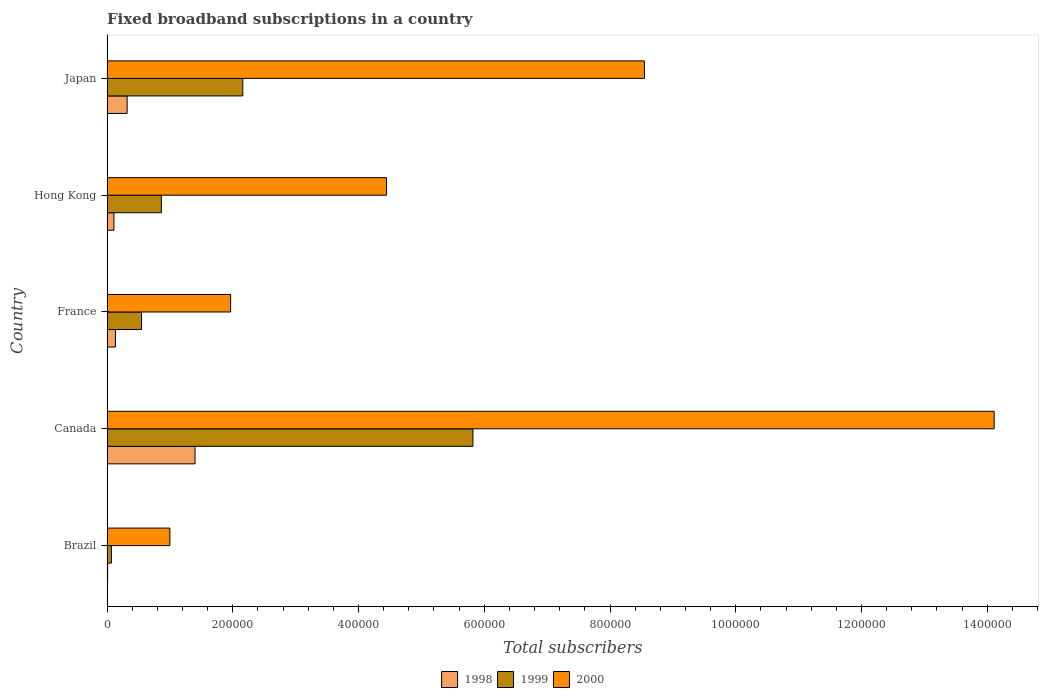How many different coloured bars are there?
Make the answer very short. 3. How many groups of bars are there?
Your answer should be very brief. 5. Are the number of bars on each tick of the Y-axis equal?
Ensure brevity in your answer.  Yes. How many bars are there on the 4th tick from the top?
Provide a succinct answer. 3. What is the label of the 5th group of bars from the top?
Make the answer very short. Brazil. What is the number of broadband subscriptions in 1998 in France?
Ensure brevity in your answer.  1.35e+04. Across all countries, what is the minimum number of broadband subscriptions in 1998?
Make the answer very short. 1000. In which country was the number of broadband subscriptions in 1998 maximum?
Your answer should be compact. Canada. In which country was the number of broadband subscriptions in 1998 minimum?
Make the answer very short. Brazil. What is the total number of broadband subscriptions in 2000 in the graph?
Provide a succinct answer. 3.01e+06. What is the difference between the number of broadband subscriptions in 1998 in Brazil and that in Canada?
Your response must be concise. -1.39e+05. What is the difference between the number of broadband subscriptions in 1999 in Hong Kong and the number of broadband subscriptions in 1998 in Brazil?
Offer a very short reply. 8.55e+04. What is the average number of broadband subscriptions in 1999 per country?
Offer a terse response. 1.89e+05. What is the difference between the number of broadband subscriptions in 1999 and number of broadband subscriptions in 2000 in France?
Give a very brief answer. -1.42e+05. In how many countries, is the number of broadband subscriptions in 2000 greater than 1240000 ?
Offer a terse response. 1. What is the ratio of the number of broadband subscriptions in 2000 in Brazil to that in Hong Kong?
Offer a very short reply. 0.22. Is the number of broadband subscriptions in 2000 in Canada less than that in Japan?
Offer a very short reply. No. What is the difference between the highest and the second highest number of broadband subscriptions in 1998?
Ensure brevity in your answer.  1.08e+05. What is the difference between the highest and the lowest number of broadband subscriptions in 1999?
Provide a succinct answer. 5.75e+05. What does the 1st bar from the bottom in Japan represents?
Ensure brevity in your answer.  1998. How many bars are there?
Give a very brief answer. 15. Are all the bars in the graph horizontal?
Your response must be concise. Yes. What is the difference between two consecutive major ticks on the X-axis?
Make the answer very short. 2.00e+05. Does the graph contain grids?
Offer a terse response. No. How are the legend labels stacked?
Provide a succinct answer. Horizontal. What is the title of the graph?
Keep it short and to the point. Fixed broadband subscriptions in a country. Does "1973" appear as one of the legend labels in the graph?
Make the answer very short. No. What is the label or title of the X-axis?
Provide a short and direct response. Total subscribers. What is the label or title of the Y-axis?
Your answer should be compact. Country. What is the Total subscribers of 1999 in Brazil?
Provide a succinct answer. 7000. What is the Total subscribers of 2000 in Brazil?
Your response must be concise. 1.00e+05. What is the Total subscribers of 1998 in Canada?
Give a very brief answer. 1.40e+05. What is the Total subscribers of 1999 in Canada?
Keep it short and to the point. 5.82e+05. What is the Total subscribers of 2000 in Canada?
Give a very brief answer. 1.41e+06. What is the Total subscribers of 1998 in France?
Keep it short and to the point. 1.35e+04. What is the Total subscribers in 1999 in France?
Offer a terse response. 5.50e+04. What is the Total subscribers of 2000 in France?
Your answer should be very brief. 1.97e+05. What is the Total subscribers of 1998 in Hong Kong?
Your answer should be very brief. 1.10e+04. What is the Total subscribers of 1999 in Hong Kong?
Keep it short and to the point. 8.65e+04. What is the Total subscribers of 2000 in Hong Kong?
Ensure brevity in your answer.  4.44e+05. What is the Total subscribers of 1998 in Japan?
Your response must be concise. 3.20e+04. What is the Total subscribers of 1999 in Japan?
Ensure brevity in your answer.  2.16e+05. What is the Total subscribers in 2000 in Japan?
Offer a very short reply. 8.55e+05. Across all countries, what is the maximum Total subscribers in 1999?
Your answer should be very brief. 5.82e+05. Across all countries, what is the maximum Total subscribers in 2000?
Keep it short and to the point. 1.41e+06. Across all countries, what is the minimum Total subscribers of 1998?
Offer a terse response. 1000. Across all countries, what is the minimum Total subscribers in 1999?
Provide a succinct answer. 7000. Across all countries, what is the minimum Total subscribers of 2000?
Give a very brief answer. 1.00e+05. What is the total Total subscribers in 1998 in the graph?
Keep it short and to the point. 1.97e+05. What is the total Total subscribers in 1999 in the graph?
Provide a short and direct response. 9.46e+05. What is the total Total subscribers in 2000 in the graph?
Your answer should be very brief. 3.01e+06. What is the difference between the Total subscribers of 1998 in Brazil and that in Canada?
Give a very brief answer. -1.39e+05. What is the difference between the Total subscribers of 1999 in Brazil and that in Canada?
Ensure brevity in your answer.  -5.75e+05. What is the difference between the Total subscribers of 2000 in Brazil and that in Canada?
Offer a terse response. -1.31e+06. What is the difference between the Total subscribers in 1998 in Brazil and that in France?
Make the answer very short. -1.25e+04. What is the difference between the Total subscribers in 1999 in Brazil and that in France?
Your answer should be very brief. -4.80e+04. What is the difference between the Total subscribers in 2000 in Brazil and that in France?
Your response must be concise. -9.66e+04. What is the difference between the Total subscribers in 1999 in Brazil and that in Hong Kong?
Ensure brevity in your answer.  -7.95e+04. What is the difference between the Total subscribers in 2000 in Brazil and that in Hong Kong?
Ensure brevity in your answer.  -3.44e+05. What is the difference between the Total subscribers in 1998 in Brazil and that in Japan?
Offer a very short reply. -3.10e+04. What is the difference between the Total subscribers of 1999 in Brazil and that in Japan?
Offer a very short reply. -2.09e+05. What is the difference between the Total subscribers in 2000 in Brazil and that in Japan?
Your answer should be very brief. -7.55e+05. What is the difference between the Total subscribers in 1998 in Canada and that in France?
Provide a short and direct response. 1.27e+05. What is the difference between the Total subscribers of 1999 in Canada and that in France?
Provide a short and direct response. 5.27e+05. What is the difference between the Total subscribers of 2000 in Canada and that in France?
Your answer should be very brief. 1.21e+06. What is the difference between the Total subscribers in 1998 in Canada and that in Hong Kong?
Offer a terse response. 1.29e+05. What is the difference between the Total subscribers of 1999 in Canada and that in Hong Kong?
Make the answer very short. 4.96e+05. What is the difference between the Total subscribers in 2000 in Canada and that in Hong Kong?
Keep it short and to the point. 9.66e+05. What is the difference between the Total subscribers of 1998 in Canada and that in Japan?
Your answer should be compact. 1.08e+05. What is the difference between the Total subscribers of 1999 in Canada and that in Japan?
Make the answer very short. 3.66e+05. What is the difference between the Total subscribers in 2000 in Canada and that in Japan?
Give a very brief answer. 5.56e+05. What is the difference between the Total subscribers in 1998 in France and that in Hong Kong?
Keep it short and to the point. 2464. What is the difference between the Total subscribers in 1999 in France and that in Hong Kong?
Your answer should be very brief. -3.15e+04. What is the difference between the Total subscribers in 2000 in France and that in Hong Kong?
Your response must be concise. -2.48e+05. What is the difference between the Total subscribers in 1998 in France and that in Japan?
Give a very brief answer. -1.85e+04. What is the difference between the Total subscribers of 1999 in France and that in Japan?
Offer a very short reply. -1.61e+05. What is the difference between the Total subscribers of 2000 in France and that in Japan?
Provide a succinct answer. -6.58e+05. What is the difference between the Total subscribers of 1998 in Hong Kong and that in Japan?
Provide a short and direct response. -2.10e+04. What is the difference between the Total subscribers in 1999 in Hong Kong and that in Japan?
Make the answer very short. -1.30e+05. What is the difference between the Total subscribers of 2000 in Hong Kong and that in Japan?
Provide a short and direct response. -4.10e+05. What is the difference between the Total subscribers of 1998 in Brazil and the Total subscribers of 1999 in Canada?
Offer a very short reply. -5.81e+05. What is the difference between the Total subscribers of 1998 in Brazil and the Total subscribers of 2000 in Canada?
Your response must be concise. -1.41e+06. What is the difference between the Total subscribers in 1999 in Brazil and the Total subscribers in 2000 in Canada?
Your response must be concise. -1.40e+06. What is the difference between the Total subscribers of 1998 in Brazil and the Total subscribers of 1999 in France?
Provide a short and direct response. -5.40e+04. What is the difference between the Total subscribers of 1998 in Brazil and the Total subscribers of 2000 in France?
Offer a very short reply. -1.96e+05. What is the difference between the Total subscribers of 1999 in Brazil and the Total subscribers of 2000 in France?
Provide a succinct answer. -1.90e+05. What is the difference between the Total subscribers of 1998 in Brazil and the Total subscribers of 1999 in Hong Kong?
Ensure brevity in your answer.  -8.55e+04. What is the difference between the Total subscribers of 1998 in Brazil and the Total subscribers of 2000 in Hong Kong?
Your response must be concise. -4.43e+05. What is the difference between the Total subscribers of 1999 in Brazil and the Total subscribers of 2000 in Hong Kong?
Provide a succinct answer. -4.37e+05. What is the difference between the Total subscribers in 1998 in Brazil and the Total subscribers in 1999 in Japan?
Offer a very short reply. -2.15e+05. What is the difference between the Total subscribers of 1998 in Brazil and the Total subscribers of 2000 in Japan?
Your response must be concise. -8.54e+05. What is the difference between the Total subscribers in 1999 in Brazil and the Total subscribers in 2000 in Japan?
Give a very brief answer. -8.48e+05. What is the difference between the Total subscribers in 1998 in Canada and the Total subscribers in 1999 in France?
Your answer should be compact. 8.50e+04. What is the difference between the Total subscribers of 1998 in Canada and the Total subscribers of 2000 in France?
Provide a succinct answer. -5.66e+04. What is the difference between the Total subscribers of 1999 in Canada and the Total subscribers of 2000 in France?
Keep it short and to the point. 3.85e+05. What is the difference between the Total subscribers in 1998 in Canada and the Total subscribers in 1999 in Hong Kong?
Keep it short and to the point. 5.35e+04. What is the difference between the Total subscribers of 1998 in Canada and the Total subscribers of 2000 in Hong Kong?
Give a very brief answer. -3.04e+05. What is the difference between the Total subscribers in 1999 in Canada and the Total subscribers in 2000 in Hong Kong?
Provide a succinct answer. 1.38e+05. What is the difference between the Total subscribers in 1998 in Canada and the Total subscribers in 1999 in Japan?
Ensure brevity in your answer.  -7.60e+04. What is the difference between the Total subscribers in 1998 in Canada and the Total subscribers in 2000 in Japan?
Your response must be concise. -7.15e+05. What is the difference between the Total subscribers in 1999 in Canada and the Total subscribers in 2000 in Japan?
Your response must be concise. -2.73e+05. What is the difference between the Total subscribers in 1998 in France and the Total subscribers in 1999 in Hong Kong?
Provide a short and direct response. -7.30e+04. What is the difference between the Total subscribers of 1998 in France and the Total subscribers of 2000 in Hong Kong?
Give a very brief answer. -4.31e+05. What is the difference between the Total subscribers in 1999 in France and the Total subscribers in 2000 in Hong Kong?
Provide a short and direct response. -3.89e+05. What is the difference between the Total subscribers in 1998 in France and the Total subscribers in 1999 in Japan?
Keep it short and to the point. -2.03e+05. What is the difference between the Total subscribers of 1998 in France and the Total subscribers of 2000 in Japan?
Make the answer very short. -8.41e+05. What is the difference between the Total subscribers in 1999 in France and the Total subscribers in 2000 in Japan?
Your answer should be compact. -8.00e+05. What is the difference between the Total subscribers in 1998 in Hong Kong and the Total subscribers in 1999 in Japan?
Your answer should be very brief. -2.05e+05. What is the difference between the Total subscribers in 1998 in Hong Kong and the Total subscribers in 2000 in Japan?
Ensure brevity in your answer.  -8.44e+05. What is the difference between the Total subscribers in 1999 in Hong Kong and the Total subscribers in 2000 in Japan?
Your answer should be compact. -7.68e+05. What is the average Total subscribers of 1998 per country?
Give a very brief answer. 3.95e+04. What is the average Total subscribers in 1999 per country?
Give a very brief answer. 1.89e+05. What is the average Total subscribers of 2000 per country?
Ensure brevity in your answer.  6.01e+05. What is the difference between the Total subscribers of 1998 and Total subscribers of 1999 in Brazil?
Ensure brevity in your answer.  -6000. What is the difference between the Total subscribers of 1998 and Total subscribers of 2000 in Brazil?
Your answer should be compact. -9.90e+04. What is the difference between the Total subscribers of 1999 and Total subscribers of 2000 in Brazil?
Offer a very short reply. -9.30e+04. What is the difference between the Total subscribers of 1998 and Total subscribers of 1999 in Canada?
Ensure brevity in your answer.  -4.42e+05. What is the difference between the Total subscribers of 1998 and Total subscribers of 2000 in Canada?
Make the answer very short. -1.27e+06. What is the difference between the Total subscribers of 1999 and Total subscribers of 2000 in Canada?
Make the answer very short. -8.29e+05. What is the difference between the Total subscribers of 1998 and Total subscribers of 1999 in France?
Provide a short and direct response. -4.15e+04. What is the difference between the Total subscribers in 1998 and Total subscribers in 2000 in France?
Ensure brevity in your answer.  -1.83e+05. What is the difference between the Total subscribers in 1999 and Total subscribers in 2000 in France?
Your answer should be very brief. -1.42e+05. What is the difference between the Total subscribers of 1998 and Total subscribers of 1999 in Hong Kong?
Ensure brevity in your answer.  -7.55e+04. What is the difference between the Total subscribers of 1998 and Total subscribers of 2000 in Hong Kong?
Your response must be concise. -4.33e+05. What is the difference between the Total subscribers in 1999 and Total subscribers in 2000 in Hong Kong?
Provide a succinct answer. -3.58e+05. What is the difference between the Total subscribers in 1998 and Total subscribers in 1999 in Japan?
Your answer should be compact. -1.84e+05. What is the difference between the Total subscribers of 1998 and Total subscribers of 2000 in Japan?
Give a very brief answer. -8.23e+05. What is the difference between the Total subscribers of 1999 and Total subscribers of 2000 in Japan?
Make the answer very short. -6.39e+05. What is the ratio of the Total subscribers of 1998 in Brazil to that in Canada?
Give a very brief answer. 0.01. What is the ratio of the Total subscribers of 1999 in Brazil to that in Canada?
Offer a very short reply. 0.01. What is the ratio of the Total subscribers of 2000 in Brazil to that in Canada?
Provide a short and direct response. 0.07. What is the ratio of the Total subscribers in 1998 in Brazil to that in France?
Give a very brief answer. 0.07. What is the ratio of the Total subscribers in 1999 in Brazil to that in France?
Your answer should be compact. 0.13. What is the ratio of the Total subscribers in 2000 in Brazil to that in France?
Offer a terse response. 0.51. What is the ratio of the Total subscribers in 1998 in Brazil to that in Hong Kong?
Provide a succinct answer. 0.09. What is the ratio of the Total subscribers in 1999 in Brazil to that in Hong Kong?
Give a very brief answer. 0.08. What is the ratio of the Total subscribers of 2000 in Brazil to that in Hong Kong?
Your answer should be compact. 0.23. What is the ratio of the Total subscribers of 1998 in Brazil to that in Japan?
Your response must be concise. 0.03. What is the ratio of the Total subscribers in 1999 in Brazil to that in Japan?
Offer a terse response. 0.03. What is the ratio of the Total subscribers of 2000 in Brazil to that in Japan?
Your response must be concise. 0.12. What is the ratio of the Total subscribers in 1998 in Canada to that in France?
Your answer should be very brief. 10.4. What is the ratio of the Total subscribers of 1999 in Canada to that in France?
Your answer should be very brief. 10.58. What is the ratio of the Total subscribers of 2000 in Canada to that in France?
Provide a succinct answer. 7.18. What is the ratio of the Total subscribers in 1998 in Canada to that in Hong Kong?
Provide a succinct answer. 12.73. What is the ratio of the Total subscribers of 1999 in Canada to that in Hong Kong?
Ensure brevity in your answer.  6.73. What is the ratio of the Total subscribers of 2000 in Canada to that in Hong Kong?
Offer a very short reply. 3.17. What is the ratio of the Total subscribers of 1998 in Canada to that in Japan?
Ensure brevity in your answer.  4.38. What is the ratio of the Total subscribers in 1999 in Canada to that in Japan?
Keep it short and to the point. 2.69. What is the ratio of the Total subscribers of 2000 in Canada to that in Japan?
Provide a succinct answer. 1.65. What is the ratio of the Total subscribers in 1998 in France to that in Hong Kong?
Your response must be concise. 1.22. What is the ratio of the Total subscribers of 1999 in France to that in Hong Kong?
Offer a very short reply. 0.64. What is the ratio of the Total subscribers in 2000 in France to that in Hong Kong?
Your answer should be compact. 0.44. What is the ratio of the Total subscribers of 1998 in France to that in Japan?
Your response must be concise. 0.42. What is the ratio of the Total subscribers of 1999 in France to that in Japan?
Offer a very short reply. 0.25. What is the ratio of the Total subscribers in 2000 in France to that in Japan?
Offer a terse response. 0.23. What is the ratio of the Total subscribers in 1998 in Hong Kong to that in Japan?
Provide a succinct answer. 0.34. What is the ratio of the Total subscribers in 1999 in Hong Kong to that in Japan?
Provide a succinct answer. 0.4. What is the ratio of the Total subscribers of 2000 in Hong Kong to that in Japan?
Your answer should be compact. 0.52. What is the difference between the highest and the second highest Total subscribers in 1998?
Offer a terse response. 1.08e+05. What is the difference between the highest and the second highest Total subscribers in 1999?
Provide a succinct answer. 3.66e+05. What is the difference between the highest and the second highest Total subscribers of 2000?
Offer a very short reply. 5.56e+05. What is the difference between the highest and the lowest Total subscribers in 1998?
Provide a succinct answer. 1.39e+05. What is the difference between the highest and the lowest Total subscribers of 1999?
Keep it short and to the point. 5.75e+05. What is the difference between the highest and the lowest Total subscribers in 2000?
Your answer should be compact. 1.31e+06. 